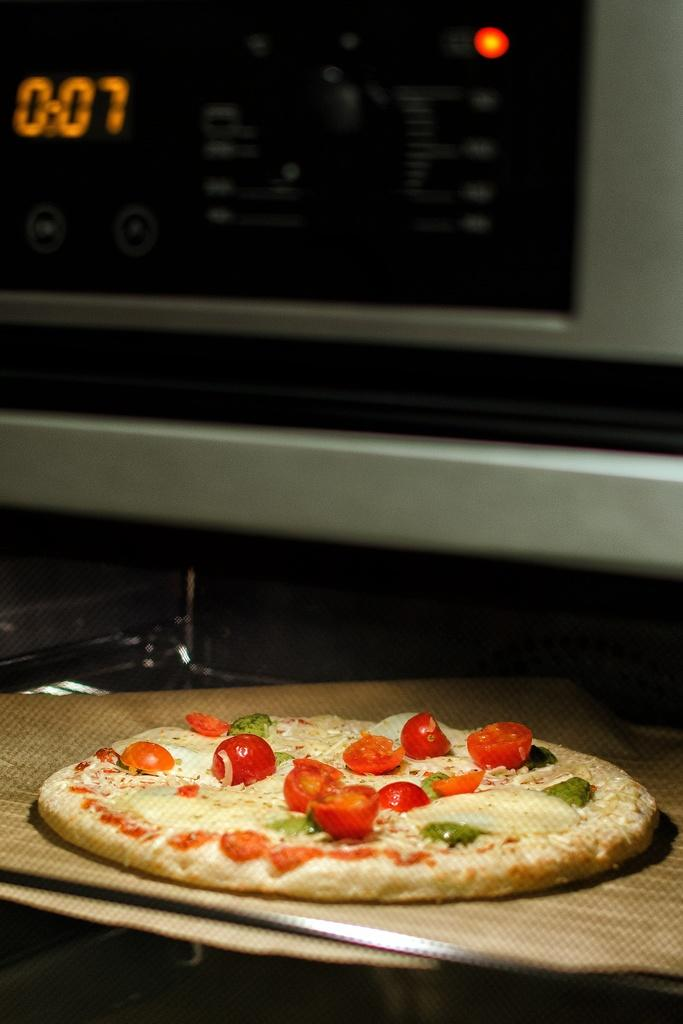Provide a one-sentence caption for the provided image. Pizza on a wooden board in front of a microwave at 0:07 seconds. 